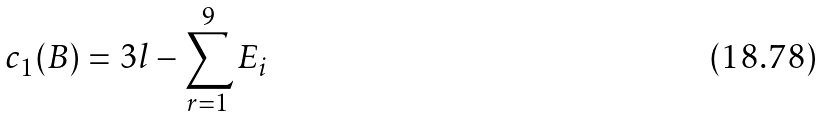<formula> <loc_0><loc_0><loc_500><loc_500>c _ { 1 } ( B ) = 3 l - \sum _ { r = 1 } ^ { 9 } E _ { i }</formula> 